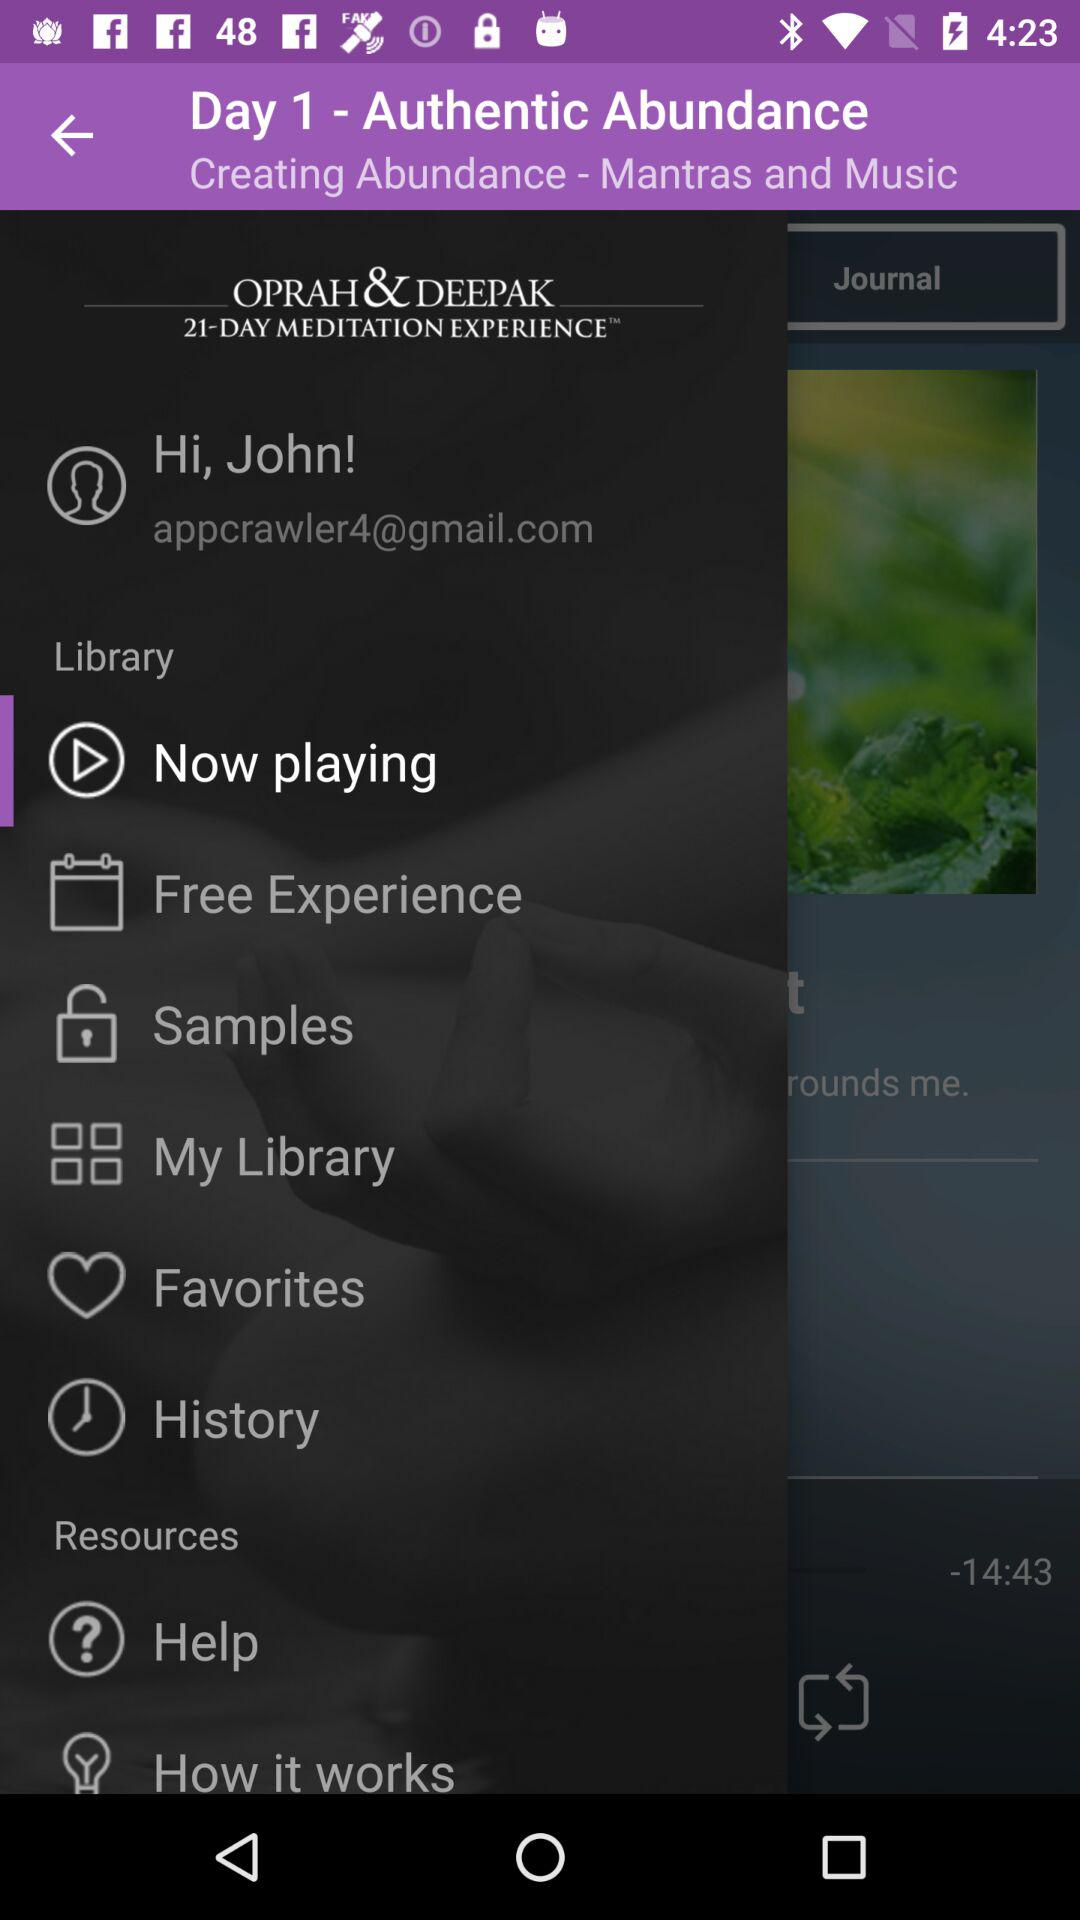What is the email address? The email address is appcrawler4@gmail.com. 